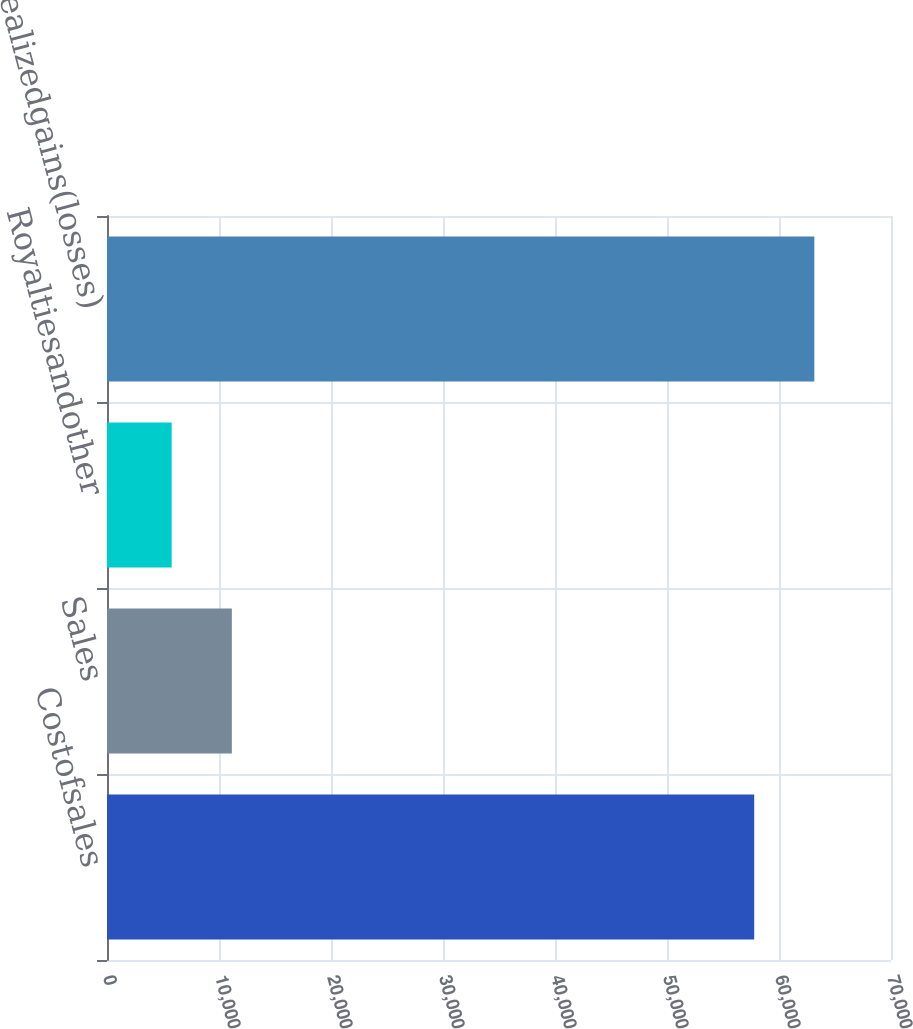Convert chart to OTSL. <chart><loc_0><loc_0><loc_500><loc_500><bar_chart><fcel>Costofsales<fcel>Sales<fcel>Royaltiesandother<fcel>Netrealizedgains(losses)<nl><fcel>57786<fcel>11146.1<fcel>5776<fcel>63156.1<nl></chart> 